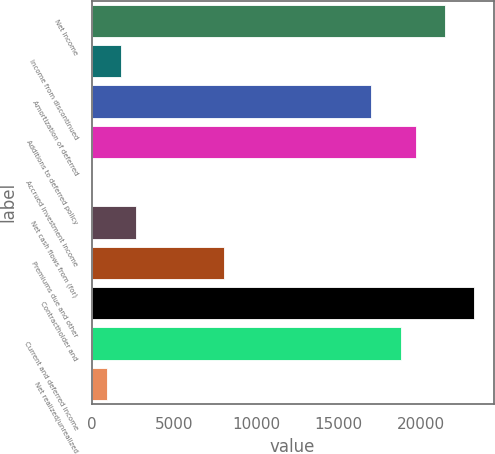Convert chart to OTSL. <chart><loc_0><loc_0><loc_500><loc_500><bar_chart><fcel>Net Income<fcel>Income from discontinued<fcel>Amortization of deferred<fcel>Additions to deferred policy<fcel>Accrued investment income<fcel>Net cash flows from (for)<fcel>Premiums due and other<fcel>Contractholder and<fcel>Current and deferred income<fcel>Net realized/unrealized<nl><fcel>21485.4<fcel>1794.94<fcel>17010.3<fcel>19695.3<fcel>4.9<fcel>2689.96<fcel>8060.08<fcel>23275.4<fcel>18800.3<fcel>899.92<nl></chart> 